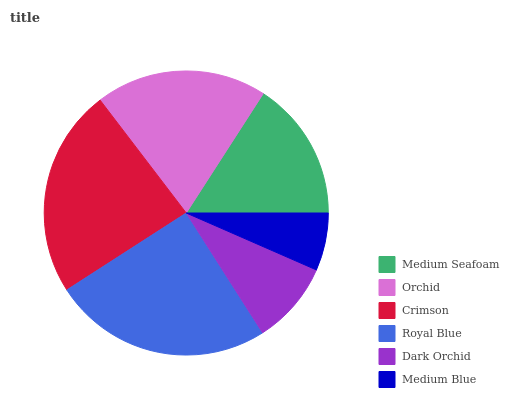Is Medium Blue the minimum?
Answer yes or no. Yes. Is Royal Blue the maximum?
Answer yes or no. Yes. Is Orchid the minimum?
Answer yes or no. No. Is Orchid the maximum?
Answer yes or no. No. Is Orchid greater than Medium Seafoam?
Answer yes or no. Yes. Is Medium Seafoam less than Orchid?
Answer yes or no. Yes. Is Medium Seafoam greater than Orchid?
Answer yes or no. No. Is Orchid less than Medium Seafoam?
Answer yes or no. No. Is Orchid the high median?
Answer yes or no. Yes. Is Medium Seafoam the low median?
Answer yes or no. Yes. Is Crimson the high median?
Answer yes or no. No. Is Orchid the low median?
Answer yes or no. No. 